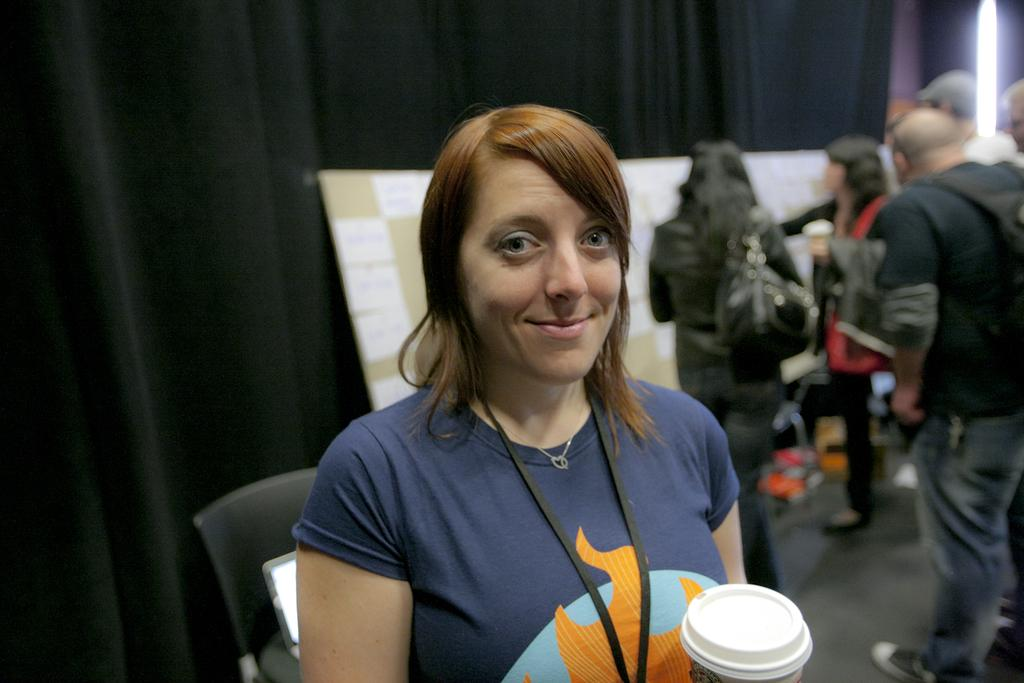Who is the main subject in the image? There is a lady in the center of the image. What is the lady holding in her hand? The lady is holding a cup in her hand. Can you describe the background of the image? There are people standing in the background of the image. What color is the cloth visible in the image? There is a black color cloth in the image. What type of activity is the lady participating in with the addition of a smash? There is no smash or activity involving a smash present in the image. 